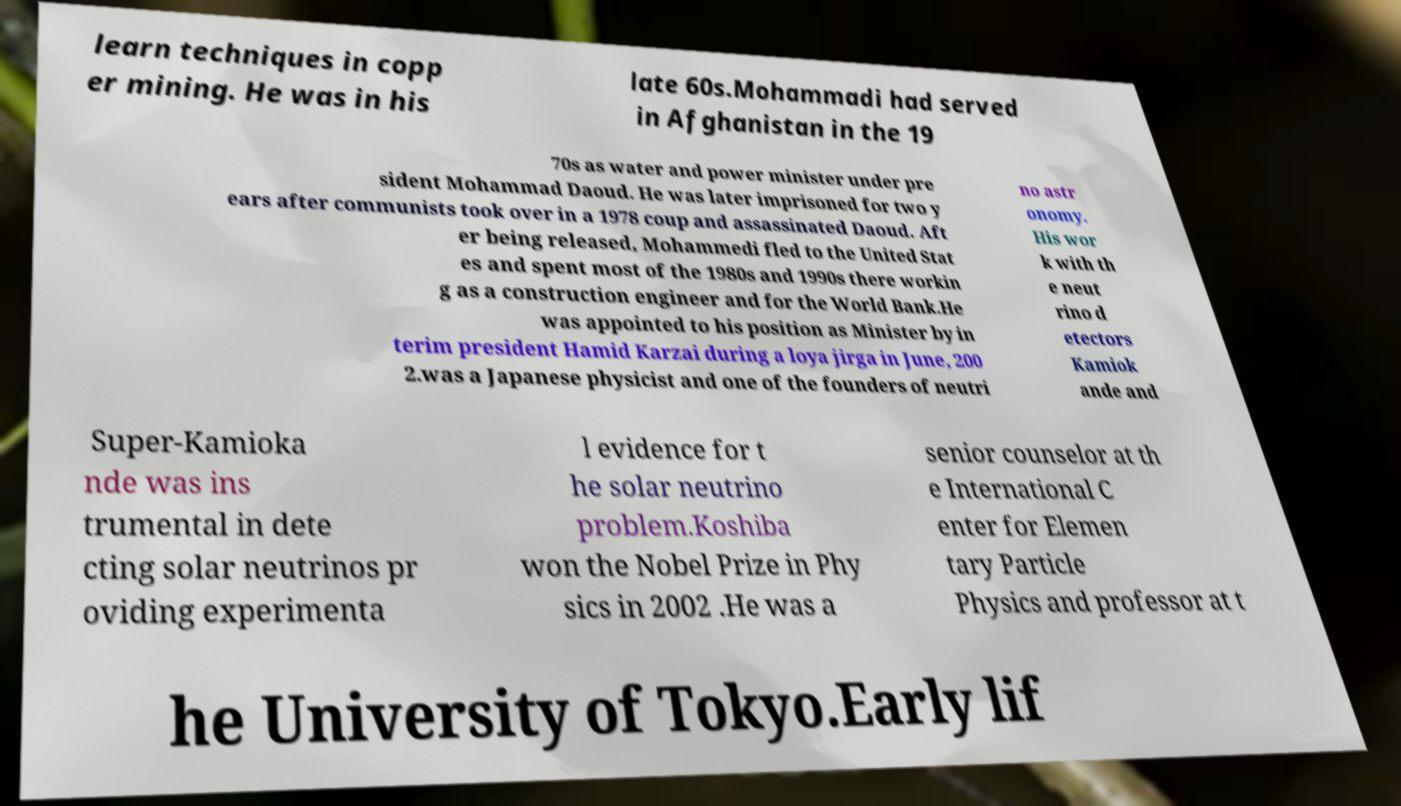Could you extract and type out the text from this image? learn techniques in copp er mining. He was in his late 60s.Mohammadi had served in Afghanistan in the 19 70s as water and power minister under pre sident Mohammad Daoud. He was later imprisoned for two y ears after communists took over in a 1978 coup and assassinated Daoud. Aft er being released, Mohammedi fled to the United Stat es and spent most of the 1980s and 1990s there workin g as a construction engineer and for the World Bank.He was appointed to his position as Minister by in terim president Hamid Karzai during a loya jirga in June, 200 2.was a Japanese physicist and one of the founders of neutri no astr onomy. His wor k with th e neut rino d etectors Kamiok ande and Super-Kamioka nde was ins trumental in dete cting solar neutrinos pr oviding experimenta l evidence for t he solar neutrino problem.Koshiba won the Nobel Prize in Phy sics in 2002 .He was a senior counselor at th e International C enter for Elemen tary Particle Physics and professor at t he University of Tokyo.Early lif 